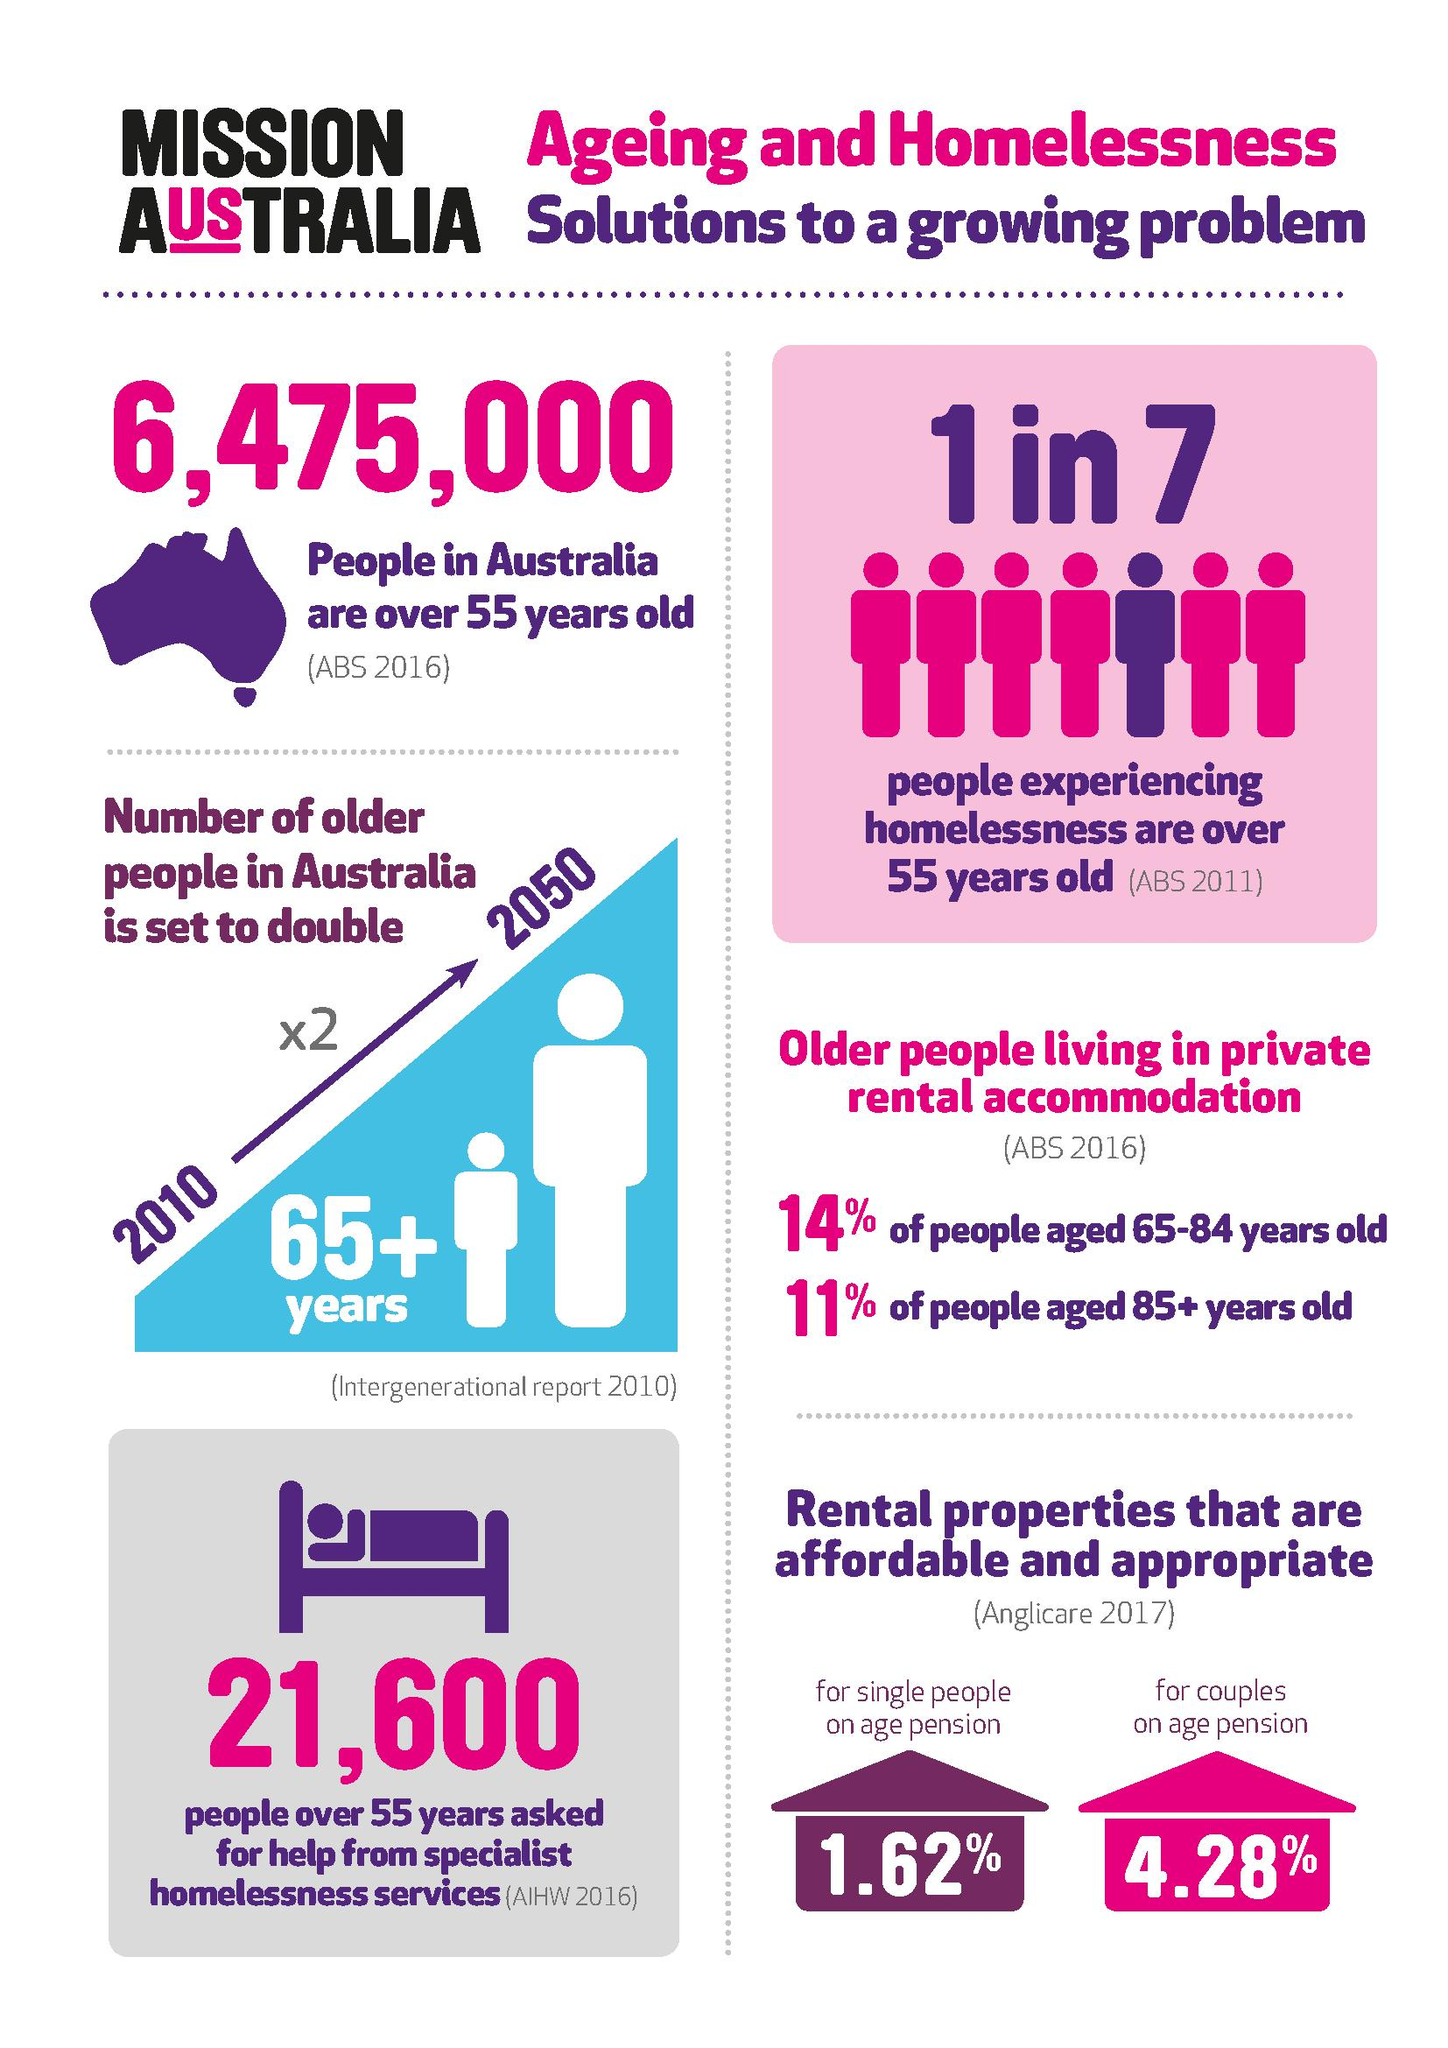Point out several critical features in this image. According to the Intergenerational Report 2010, the number of senior citizens in Australia is expected to double by 2050. According to recent statistics, approximately 14% of Australians aged fifty five and older are homeless, equating to one in seven individuals in this age group. According to a survey conducted by the Australian Bureau of Statistics in 2011, one in seven Australians are homeless. The population of Australia who are aged 55 and over is approximately 6,475,000. The allowance of 4.28% rent is permitted for certain individuals, specifically couples receiving the age pension. 